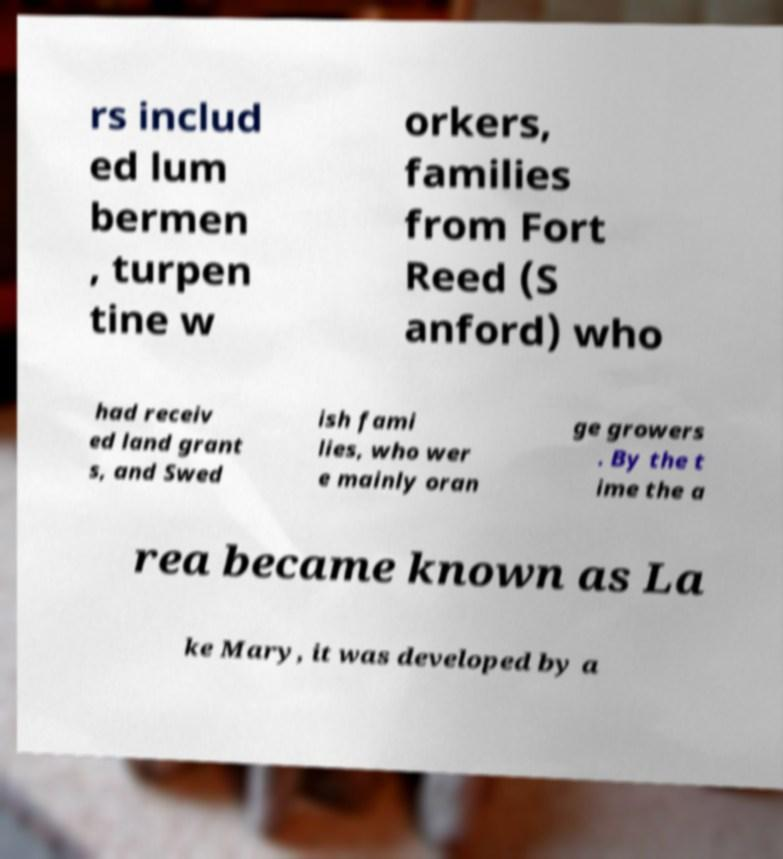Could you assist in decoding the text presented in this image and type it out clearly? rs includ ed lum bermen , turpen tine w orkers, families from Fort Reed (S anford) who had receiv ed land grant s, and Swed ish fami lies, who wer e mainly oran ge growers . By the t ime the a rea became known as La ke Mary, it was developed by a 